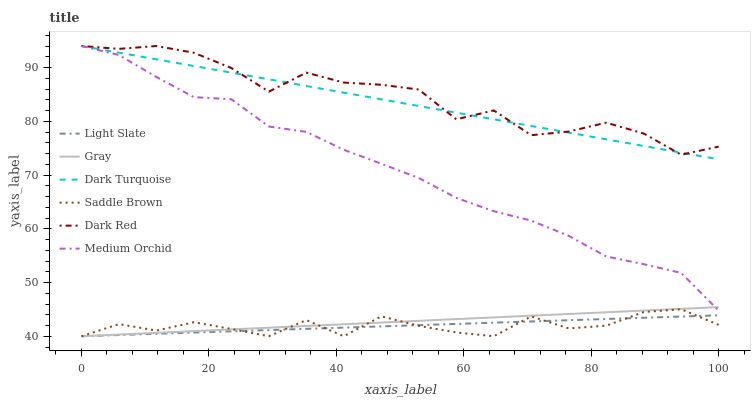Does Light Slate have the minimum area under the curve?
Answer yes or no. Yes. Does Dark Red have the maximum area under the curve?
Answer yes or no. Yes. Does Dark Red have the minimum area under the curve?
Answer yes or no. No. Does Light Slate have the maximum area under the curve?
Answer yes or no. No. Is Gray the smoothest?
Answer yes or no. Yes. Is Dark Red the roughest?
Answer yes or no. Yes. Is Light Slate the smoothest?
Answer yes or no. No. Is Light Slate the roughest?
Answer yes or no. No. Does Gray have the lowest value?
Answer yes or no. Yes. Does Dark Red have the lowest value?
Answer yes or no. No. Does Dark Turquoise have the highest value?
Answer yes or no. Yes. Does Light Slate have the highest value?
Answer yes or no. No. Is Light Slate less than Dark Red?
Answer yes or no. Yes. Is Dark Red greater than Saddle Brown?
Answer yes or no. Yes. Does Gray intersect Saddle Brown?
Answer yes or no. Yes. Is Gray less than Saddle Brown?
Answer yes or no. No. Is Gray greater than Saddle Brown?
Answer yes or no. No. Does Light Slate intersect Dark Red?
Answer yes or no. No. 